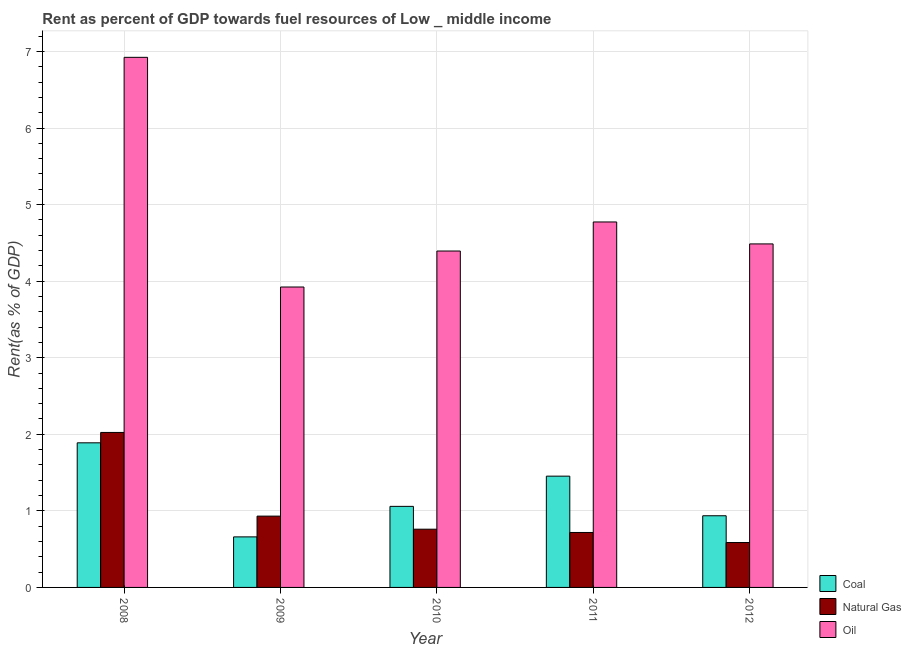How many different coloured bars are there?
Give a very brief answer. 3. How many bars are there on the 1st tick from the left?
Your answer should be very brief. 3. How many bars are there on the 2nd tick from the right?
Give a very brief answer. 3. In how many cases, is the number of bars for a given year not equal to the number of legend labels?
Your response must be concise. 0. What is the rent towards oil in 2009?
Provide a short and direct response. 3.92. Across all years, what is the maximum rent towards natural gas?
Ensure brevity in your answer.  2.02. Across all years, what is the minimum rent towards coal?
Provide a succinct answer. 0.66. In which year was the rent towards oil minimum?
Offer a very short reply. 2009. What is the total rent towards oil in the graph?
Your response must be concise. 24.5. What is the difference between the rent towards natural gas in 2011 and that in 2012?
Give a very brief answer. 0.13. What is the difference between the rent towards oil in 2008 and the rent towards natural gas in 2012?
Make the answer very short. 2.44. What is the average rent towards natural gas per year?
Provide a succinct answer. 1. In the year 2008, what is the difference between the rent towards coal and rent towards natural gas?
Ensure brevity in your answer.  0. In how many years, is the rent towards oil greater than 0.6000000000000001 %?
Give a very brief answer. 5. What is the ratio of the rent towards oil in 2010 to that in 2011?
Ensure brevity in your answer.  0.92. Is the difference between the rent towards oil in 2010 and 2011 greater than the difference between the rent towards natural gas in 2010 and 2011?
Your answer should be compact. No. What is the difference between the highest and the second highest rent towards coal?
Your answer should be very brief. 0.44. What is the difference between the highest and the lowest rent towards natural gas?
Ensure brevity in your answer.  1.44. In how many years, is the rent towards oil greater than the average rent towards oil taken over all years?
Provide a succinct answer. 1. What does the 3rd bar from the left in 2009 represents?
Offer a terse response. Oil. What does the 2nd bar from the right in 2009 represents?
Your answer should be compact. Natural Gas. Is it the case that in every year, the sum of the rent towards coal and rent towards natural gas is greater than the rent towards oil?
Give a very brief answer. No. How many bars are there?
Give a very brief answer. 15. How many years are there in the graph?
Offer a very short reply. 5. What is the difference between two consecutive major ticks on the Y-axis?
Provide a succinct answer. 1. Are the values on the major ticks of Y-axis written in scientific E-notation?
Make the answer very short. No. Does the graph contain any zero values?
Offer a terse response. No. Where does the legend appear in the graph?
Your response must be concise. Bottom right. How many legend labels are there?
Keep it short and to the point. 3. How are the legend labels stacked?
Ensure brevity in your answer.  Vertical. What is the title of the graph?
Your response must be concise. Rent as percent of GDP towards fuel resources of Low _ middle income. What is the label or title of the X-axis?
Your response must be concise. Year. What is the label or title of the Y-axis?
Ensure brevity in your answer.  Rent(as % of GDP). What is the Rent(as % of GDP) in Coal in 2008?
Ensure brevity in your answer.  1.89. What is the Rent(as % of GDP) in Natural Gas in 2008?
Your response must be concise. 2.02. What is the Rent(as % of GDP) of Oil in 2008?
Offer a very short reply. 6.92. What is the Rent(as % of GDP) in Coal in 2009?
Your answer should be very brief. 0.66. What is the Rent(as % of GDP) in Natural Gas in 2009?
Keep it short and to the point. 0.93. What is the Rent(as % of GDP) in Oil in 2009?
Make the answer very short. 3.92. What is the Rent(as % of GDP) of Coal in 2010?
Your response must be concise. 1.06. What is the Rent(as % of GDP) of Natural Gas in 2010?
Your answer should be compact. 0.76. What is the Rent(as % of GDP) in Oil in 2010?
Ensure brevity in your answer.  4.39. What is the Rent(as % of GDP) of Coal in 2011?
Your answer should be very brief. 1.45. What is the Rent(as % of GDP) in Natural Gas in 2011?
Your response must be concise. 0.72. What is the Rent(as % of GDP) of Oil in 2011?
Ensure brevity in your answer.  4.77. What is the Rent(as % of GDP) of Coal in 2012?
Keep it short and to the point. 0.94. What is the Rent(as % of GDP) in Natural Gas in 2012?
Keep it short and to the point. 0.59. What is the Rent(as % of GDP) of Oil in 2012?
Your response must be concise. 4.49. Across all years, what is the maximum Rent(as % of GDP) of Coal?
Provide a succinct answer. 1.89. Across all years, what is the maximum Rent(as % of GDP) of Natural Gas?
Offer a terse response. 2.02. Across all years, what is the maximum Rent(as % of GDP) in Oil?
Your answer should be very brief. 6.92. Across all years, what is the minimum Rent(as % of GDP) of Coal?
Keep it short and to the point. 0.66. Across all years, what is the minimum Rent(as % of GDP) in Natural Gas?
Your answer should be very brief. 0.59. Across all years, what is the minimum Rent(as % of GDP) of Oil?
Offer a very short reply. 3.92. What is the total Rent(as % of GDP) of Coal in the graph?
Your answer should be very brief. 6. What is the total Rent(as % of GDP) in Natural Gas in the graph?
Provide a succinct answer. 5.02. What is the total Rent(as % of GDP) in Oil in the graph?
Offer a very short reply. 24.5. What is the difference between the Rent(as % of GDP) in Coal in 2008 and that in 2009?
Provide a short and direct response. 1.23. What is the difference between the Rent(as % of GDP) of Natural Gas in 2008 and that in 2009?
Provide a succinct answer. 1.09. What is the difference between the Rent(as % of GDP) in Oil in 2008 and that in 2009?
Provide a succinct answer. 3. What is the difference between the Rent(as % of GDP) of Coal in 2008 and that in 2010?
Provide a succinct answer. 0.83. What is the difference between the Rent(as % of GDP) in Natural Gas in 2008 and that in 2010?
Your answer should be very brief. 1.26. What is the difference between the Rent(as % of GDP) in Oil in 2008 and that in 2010?
Your response must be concise. 2.53. What is the difference between the Rent(as % of GDP) in Coal in 2008 and that in 2011?
Offer a terse response. 0.44. What is the difference between the Rent(as % of GDP) of Natural Gas in 2008 and that in 2011?
Keep it short and to the point. 1.31. What is the difference between the Rent(as % of GDP) of Oil in 2008 and that in 2011?
Provide a succinct answer. 2.15. What is the difference between the Rent(as % of GDP) in Coal in 2008 and that in 2012?
Make the answer very short. 0.95. What is the difference between the Rent(as % of GDP) in Natural Gas in 2008 and that in 2012?
Make the answer very short. 1.44. What is the difference between the Rent(as % of GDP) of Oil in 2008 and that in 2012?
Make the answer very short. 2.44. What is the difference between the Rent(as % of GDP) in Coal in 2009 and that in 2010?
Offer a terse response. -0.4. What is the difference between the Rent(as % of GDP) in Natural Gas in 2009 and that in 2010?
Give a very brief answer. 0.17. What is the difference between the Rent(as % of GDP) of Oil in 2009 and that in 2010?
Your answer should be very brief. -0.47. What is the difference between the Rent(as % of GDP) of Coal in 2009 and that in 2011?
Your answer should be very brief. -0.79. What is the difference between the Rent(as % of GDP) in Natural Gas in 2009 and that in 2011?
Provide a short and direct response. 0.21. What is the difference between the Rent(as % of GDP) of Oil in 2009 and that in 2011?
Offer a very short reply. -0.85. What is the difference between the Rent(as % of GDP) in Coal in 2009 and that in 2012?
Keep it short and to the point. -0.28. What is the difference between the Rent(as % of GDP) of Natural Gas in 2009 and that in 2012?
Provide a succinct answer. 0.34. What is the difference between the Rent(as % of GDP) of Oil in 2009 and that in 2012?
Make the answer very short. -0.56. What is the difference between the Rent(as % of GDP) in Coal in 2010 and that in 2011?
Your answer should be compact. -0.39. What is the difference between the Rent(as % of GDP) of Natural Gas in 2010 and that in 2011?
Your answer should be very brief. 0.04. What is the difference between the Rent(as % of GDP) of Oil in 2010 and that in 2011?
Your answer should be very brief. -0.38. What is the difference between the Rent(as % of GDP) of Coal in 2010 and that in 2012?
Offer a very short reply. 0.12. What is the difference between the Rent(as % of GDP) in Natural Gas in 2010 and that in 2012?
Provide a short and direct response. 0.17. What is the difference between the Rent(as % of GDP) of Oil in 2010 and that in 2012?
Your response must be concise. -0.09. What is the difference between the Rent(as % of GDP) in Coal in 2011 and that in 2012?
Keep it short and to the point. 0.52. What is the difference between the Rent(as % of GDP) in Natural Gas in 2011 and that in 2012?
Make the answer very short. 0.13. What is the difference between the Rent(as % of GDP) of Oil in 2011 and that in 2012?
Provide a succinct answer. 0.29. What is the difference between the Rent(as % of GDP) in Coal in 2008 and the Rent(as % of GDP) in Natural Gas in 2009?
Ensure brevity in your answer.  0.96. What is the difference between the Rent(as % of GDP) in Coal in 2008 and the Rent(as % of GDP) in Oil in 2009?
Make the answer very short. -2.04. What is the difference between the Rent(as % of GDP) of Natural Gas in 2008 and the Rent(as % of GDP) of Oil in 2009?
Ensure brevity in your answer.  -1.9. What is the difference between the Rent(as % of GDP) of Coal in 2008 and the Rent(as % of GDP) of Natural Gas in 2010?
Offer a terse response. 1.13. What is the difference between the Rent(as % of GDP) of Coal in 2008 and the Rent(as % of GDP) of Oil in 2010?
Ensure brevity in your answer.  -2.51. What is the difference between the Rent(as % of GDP) of Natural Gas in 2008 and the Rent(as % of GDP) of Oil in 2010?
Offer a very short reply. -2.37. What is the difference between the Rent(as % of GDP) of Coal in 2008 and the Rent(as % of GDP) of Natural Gas in 2011?
Give a very brief answer. 1.17. What is the difference between the Rent(as % of GDP) in Coal in 2008 and the Rent(as % of GDP) in Oil in 2011?
Your answer should be compact. -2.88. What is the difference between the Rent(as % of GDP) of Natural Gas in 2008 and the Rent(as % of GDP) of Oil in 2011?
Offer a very short reply. -2.75. What is the difference between the Rent(as % of GDP) of Coal in 2008 and the Rent(as % of GDP) of Natural Gas in 2012?
Ensure brevity in your answer.  1.3. What is the difference between the Rent(as % of GDP) of Coal in 2008 and the Rent(as % of GDP) of Oil in 2012?
Your response must be concise. -2.6. What is the difference between the Rent(as % of GDP) of Natural Gas in 2008 and the Rent(as % of GDP) of Oil in 2012?
Ensure brevity in your answer.  -2.46. What is the difference between the Rent(as % of GDP) of Coal in 2009 and the Rent(as % of GDP) of Natural Gas in 2010?
Provide a short and direct response. -0.1. What is the difference between the Rent(as % of GDP) in Coal in 2009 and the Rent(as % of GDP) in Oil in 2010?
Provide a succinct answer. -3.73. What is the difference between the Rent(as % of GDP) in Natural Gas in 2009 and the Rent(as % of GDP) in Oil in 2010?
Your answer should be very brief. -3.46. What is the difference between the Rent(as % of GDP) of Coal in 2009 and the Rent(as % of GDP) of Natural Gas in 2011?
Your answer should be very brief. -0.06. What is the difference between the Rent(as % of GDP) in Coal in 2009 and the Rent(as % of GDP) in Oil in 2011?
Provide a short and direct response. -4.11. What is the difference between the Rent(as % of GDP) of Natural Gas in 2009 and the Rent(as % of GDP) of Oil in 2011?
Provide a succinct answer. -3.84. What is the difference between the Rent(as % of GDP) of Coal in 2009 and the Rent(as % of GDP) of Natural Gas in 2012?
Provide a succinct answer. 0.07. What is the difference between the Rent(as % of GDP) of Coal in 2009 and the Rent(as % of GDP) of Oil in 2012?
Provide a short and direct response. -3.83. What is the difference between the Rent(as % of GDP) in Natural Gas in 2009 and the Rent(as % of GDP) in Oil in 2012?
Ensure brevity in your answer.  -3.56. What is the difference between the Rent(as % of GDP) of Coal in 2010 and the Rent(as % of GDP) of Natural Gas in 2011?
Keep it short and to the point. 0.34. What is the difference between the Rent(as % of GDP) in Coal in 2010 and the Rent(as % of GDP) in Oil in 2011?
Keep it short and to the point. -3.71. What is the difference between the Rent(as % of GDP) in Natural Gas in 2010 and the Rent(as % of GDP) in Oil in 2011?
Offer a very short reply. -4.01. What is the difference between the Rent(as % of GDP) of Coal in 2010 and the Rent(as % of GDP) of Natural Gas in 2012?
Provide a succinct answer. 0.47. What is the difference between the Rent(as % of GDP) of Coal in 2010 and the Rent(as % of GDP) of Oil in 2012?
Offer a terse response. -3.43. What is the difference between the Rent(as % of GDP) of Natural Gas in 2010 and the Rent(as % of GDP) of Oil in 2012?
Provide a succinct answer. -3.73. What is the difference between the Rent(as % of GDP) in Coal in 2011 and the Rent(as % of GDP) in Natural Gas in 2012?
Give a very brief answer. 0.87. What is the difference between the Rent(as % of GDP) in Coal in 2011 and the Rent(as % of GDP) in Oil in 2012?
Provide a short and direct response. -3.03. What is the difference between the Rent(as % of GDP) in Natural Gas in 2011 and the Rent(as % of GDP) in Oil in 2012?
Offer a very short reply. -3.77. What is the average Rent(as % of GDP) of Coal per year?
Your answer should be very brief. 1.2. What is the average Rent(as % of GDP) in Natural Gas per year?
Your answer should be very brief. 1. What is the average Rent(as % of GDP) in Oil per year?
Your answer should be very brief. 4.9. In the year 2008, what is the difference between the Rent(as % of GDP) of Coal and Rent(as % of GDP) of Natural Gas?
Offer a very short reply. -0.14. In the year 2008, what is the difference between the Rent(as % of GDP) in Coal and Rent(as % of GDP) in Oil?
Provide a succinct answer. -5.04. In the year 2008, what is the difference between the Rent(as % of GDP) in Natural Gas and Rent(as % of GDP) in Oil?
Your answer should be compact. -4.9. In the year 2009, what is the difference between the Rent(as % of GDP) of Coal and Rent(as % of GDP) of Natural Gas?
Your response must be concise. -0.27. In the year 2009, what is the difference between the Rent(as % of GDP) of Coal and Rent(as % of GDP) of Oil?
Ensure brevity in your answer.  -3.26. In the year 2009, what is the difference between the Rent(as % of GDP) in Natural Gas and Rent(as % of GDP) in Oil?
Your answer should be very brief. -2.99. In the year 2010, what is the difference between the Rent(as % of GDP) of Coal and Rent(as % of GDP) of Natural Gas?
Keep it short and to the point. 0.3. In the year 2010, what is the difference between the Rent(as % of GDP) of Coal and Rent(as % of GDP) of Oil?
Give a very brief answer. -3.34. In the year 2010, what is the difference between the Rent(as % of GDP) in Natural Gas and Rent(as % of GDP) in Oil?
Your response must be concise. -3.63. In the year 2011, what is the difference between the Rent(as % of GDP) in Coal and Rent(as % of GDP) in Natural Gas?
Your answer should be very brief. 0.74. In the year 2011, what is the difference between the Rent(as % of GDP) in Coal and Rent(as % of GDP) in Oil?
Your answer should be very brief. -3.32. In the year 2011, what is the difference between the Rent(as % of GDP) of Natural Gas and Rent(as % of GDP) of Oil?
Give a very brief answer. -4.06. In the year 2012, what is the difference between the Rent(as % of GDP) of Coal and Rent(as % of GDP) of Natural Gas?
Your response must be concise. 0.35. In the year 2012, what is the difference between the Rent(as % of GDP) in Coal and Rent(as % of GDP) in Oil?
Provide a succinct answer. -3.55. In the year 2012, what is the difference between the Rent(as % of GDP) in Natural Gas and Rent(as % of GDP) in Oil?
Your response must be concise. -3.9. What is the ratio of the Rent(as % of GDP) of Coal in 2008 to that in 2009?
Your answer should be compact. 2.86. What is the ratio of the Rent(as % of GDP) in Natural Gas in 2008 to that in 2009?
Keep it short and to the point. 2.17. What is the ratio of the Rent(as % of GDP) of Oil in 2008 to that in 2009?
Keep it short and to the point. 1.76. What is the ratio of the Rent(as % of GDP) of Coal in 2008 to that in 2010?
Your response must be concise. 1.78. What is the ratio of the Rent(as % of GDP) of Natural Gas in 2008 to that in 2010?
Provide a short and direct response. 2.66. What is the ratio of the Rent(as % of GDP) in Oil in 2008 to that in 2010?
Your answer should be very brief. 1.58. What is the ratio of the Rent(as % of GDP) in Coal in 2008 to that in 2011?
Offer a terse response. 1.3. What is the ratio of the Rent(as % of GDP) in Natural Gas in 2008 to that in 2011?
Your answer should be compact. 2.82. What is the ratio of the Rent(as % of GDP) of Oil in 2008 to that in 2011?
Your answer should be very brief. 1.45. What is the ratio of the Rent(as % of GDP) in Coal in 2008 to that in 2012?
Offer a terse response. 2.02. What is the ratio of the Rent(as % of GDP) in Natural Gas in 2008 to that in 2012?
Offer a terse response. 3.45. What is the ratio of the Rent(as % of GDP) of Oil in 2008 to that in 2012?
Ensure brevity in your answer.  1.54. What is the ratio of the Rent(as % of GDP) of Coal in 2009 to that in 2010?
Give a very brief answer. 0.62. What is the ratio of the Rent(as % of GDP) in Natural Gas in 2009 to that in 2010?
Offer a terse response. 1.22. What is the ratio of the Rent(as % of GDP) in Oil in 2009 to that in 2010?
Offer a very short reply. 0.89. What is the ratio of the Rent(as % of GDP) of Coal in 2009 to that in 2011?
Offer a terse response. 0.45. What is the ratio of the Rent(as % of GDP) of Natural Gas in 2009 to that in 2011?
Keep it short and to the point. 1.3. What is the ratio of the Rent(as % of GDP) of Oil in 2009 to that in 2011?
Your answer should be very brief. 0.82. What is the ratio of the Rent(as % of GDP) in Coal in 2009 to that in 2012?
Provide a short and direct response. 0.71. What is the ratio of the Rent(as % of GDP) in Natural Gas in 2009 to that in 2012?
Offer a very short reply. 1.59. What is the ratio of the Rent(as % of GDP) in Oil in 2009 to that in 2012?
Your answer should be very brief. 0.87. What is the ratio of the Rent(as % of GDP) of Coal in 2010 to that in 2011?
Your response must be concise. 0.73. What is the ratio of the Rent(as % of GDP) in Natural Gas in 2010 to that in 2011?
Give a very brief answer. 1.06. What is the ratio of the Rent(as % of GDP) of Oil in 2010 to that in 2011?
Give a very brief answer. 0.92. What is the ratio of the Rent(as % of GDP) in Coal in 2010 to that in 2012?
Your answer should be very brief. 1.13. What is the ratio of the Rent(as % of GDP) in Natural Gas in 2010 to that in 2012?
Your answer should be very brief. 1.3. What is the ratio of the Rent(as % of GDP) in Oil in 2010 to that in 2012?
Your answer should be very brief. 0.98. What is the ratio of the Rent(as % of GDP) in Coal in 2011 to that in 2012?
Your answer should be compact. 1.55. What is the ratio of the Rent(as % of GDP) in Natural Gas in 2011 to that in 2012?
Make the answer very short. 1.22. What is the ratio of the Rent(as % of GDP) in Oil in 2011 to that in 2012?
Your response must be concise. 1.06. What is the difference between the highest and the second highest Rent(as % of GDP) in Coal?
Ensure brevity in your answer.  0.44. What is the difference between the highest and the second highest Rent(as % of GDP) of Natural Gas?
Keep it short and to the point. 1.09. What is the difference between the highest and the second highest Rent(as % of GDP) in Oil?
Your answer should be very brief. 2.15. What is the difference between the highest and the lowest Rent(as % of GDP) of Coal?
Your answer should be compact. 1.23. What is the difference between the highest and the lowest Rent(as % of GDP) in Natural Gas?
Keep it short and to the point. 1.44. What is the difference between the highest and the lowest Rent(as % of GDP) in Oil?
Keep it short and to the point. 3. 